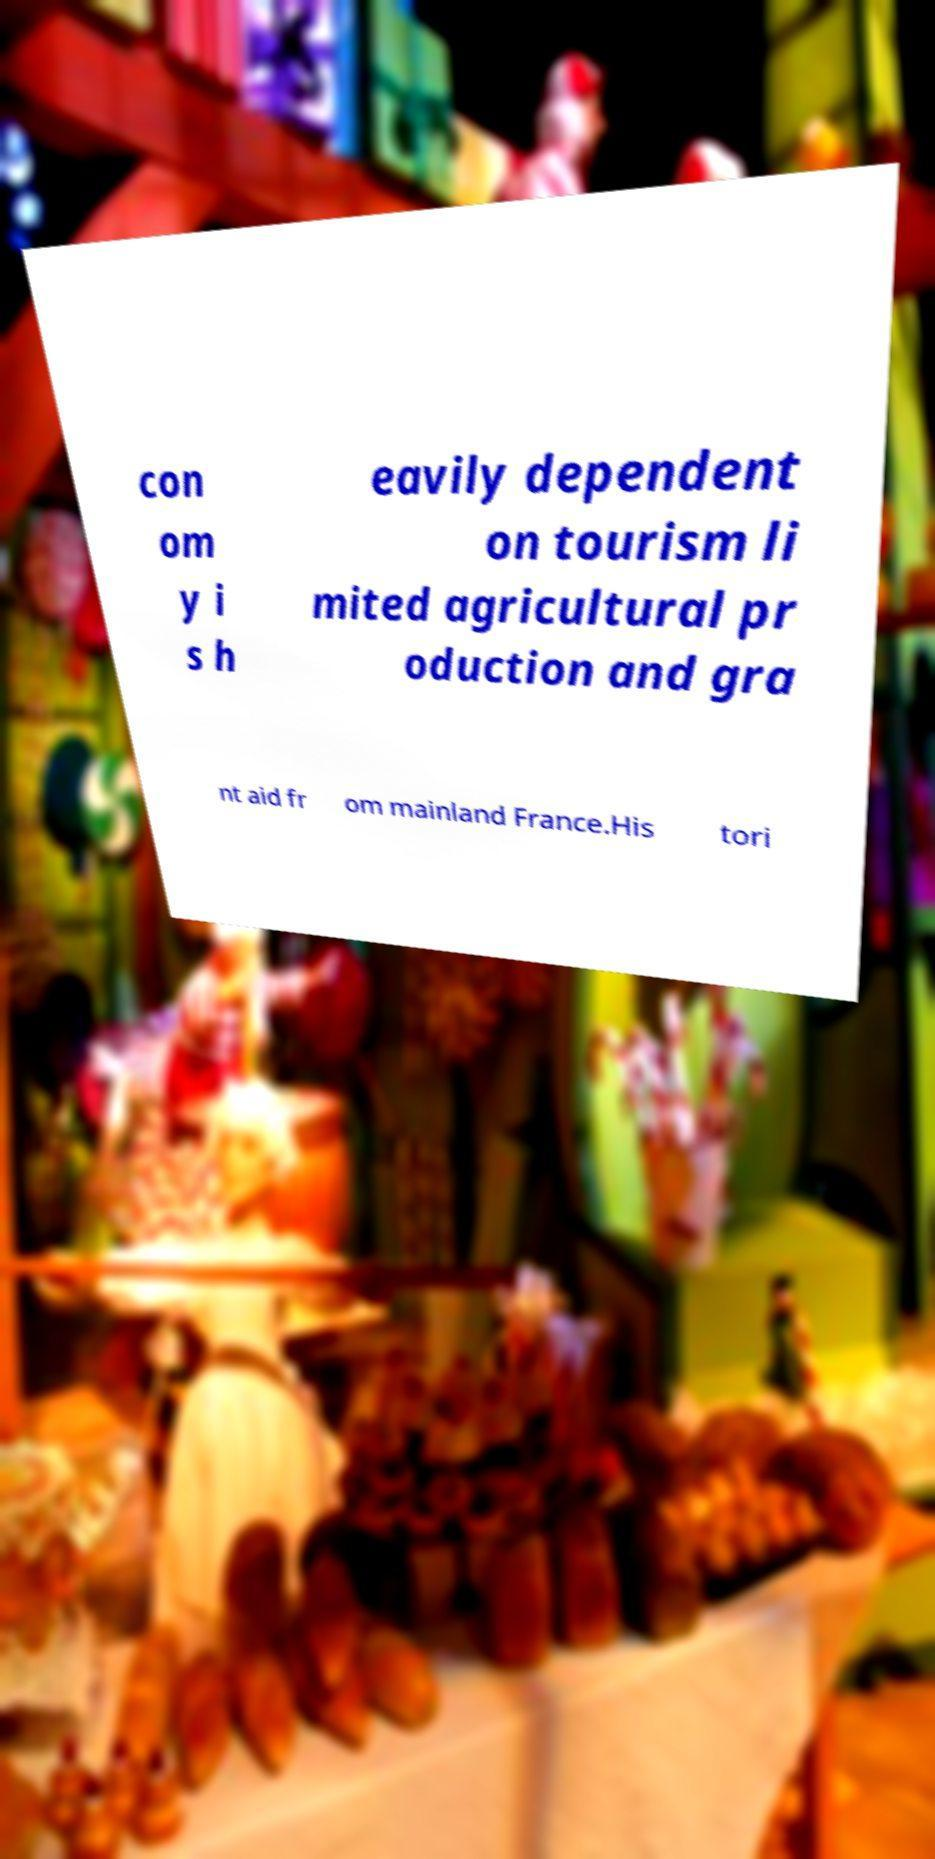There's text embedded in this image that I need extracted. Can you transcribe it verbatim? con om y i s h eavily dependent on tourism li mited agricultural pr oduction and gra nt aid fr om mainland France.His tori 